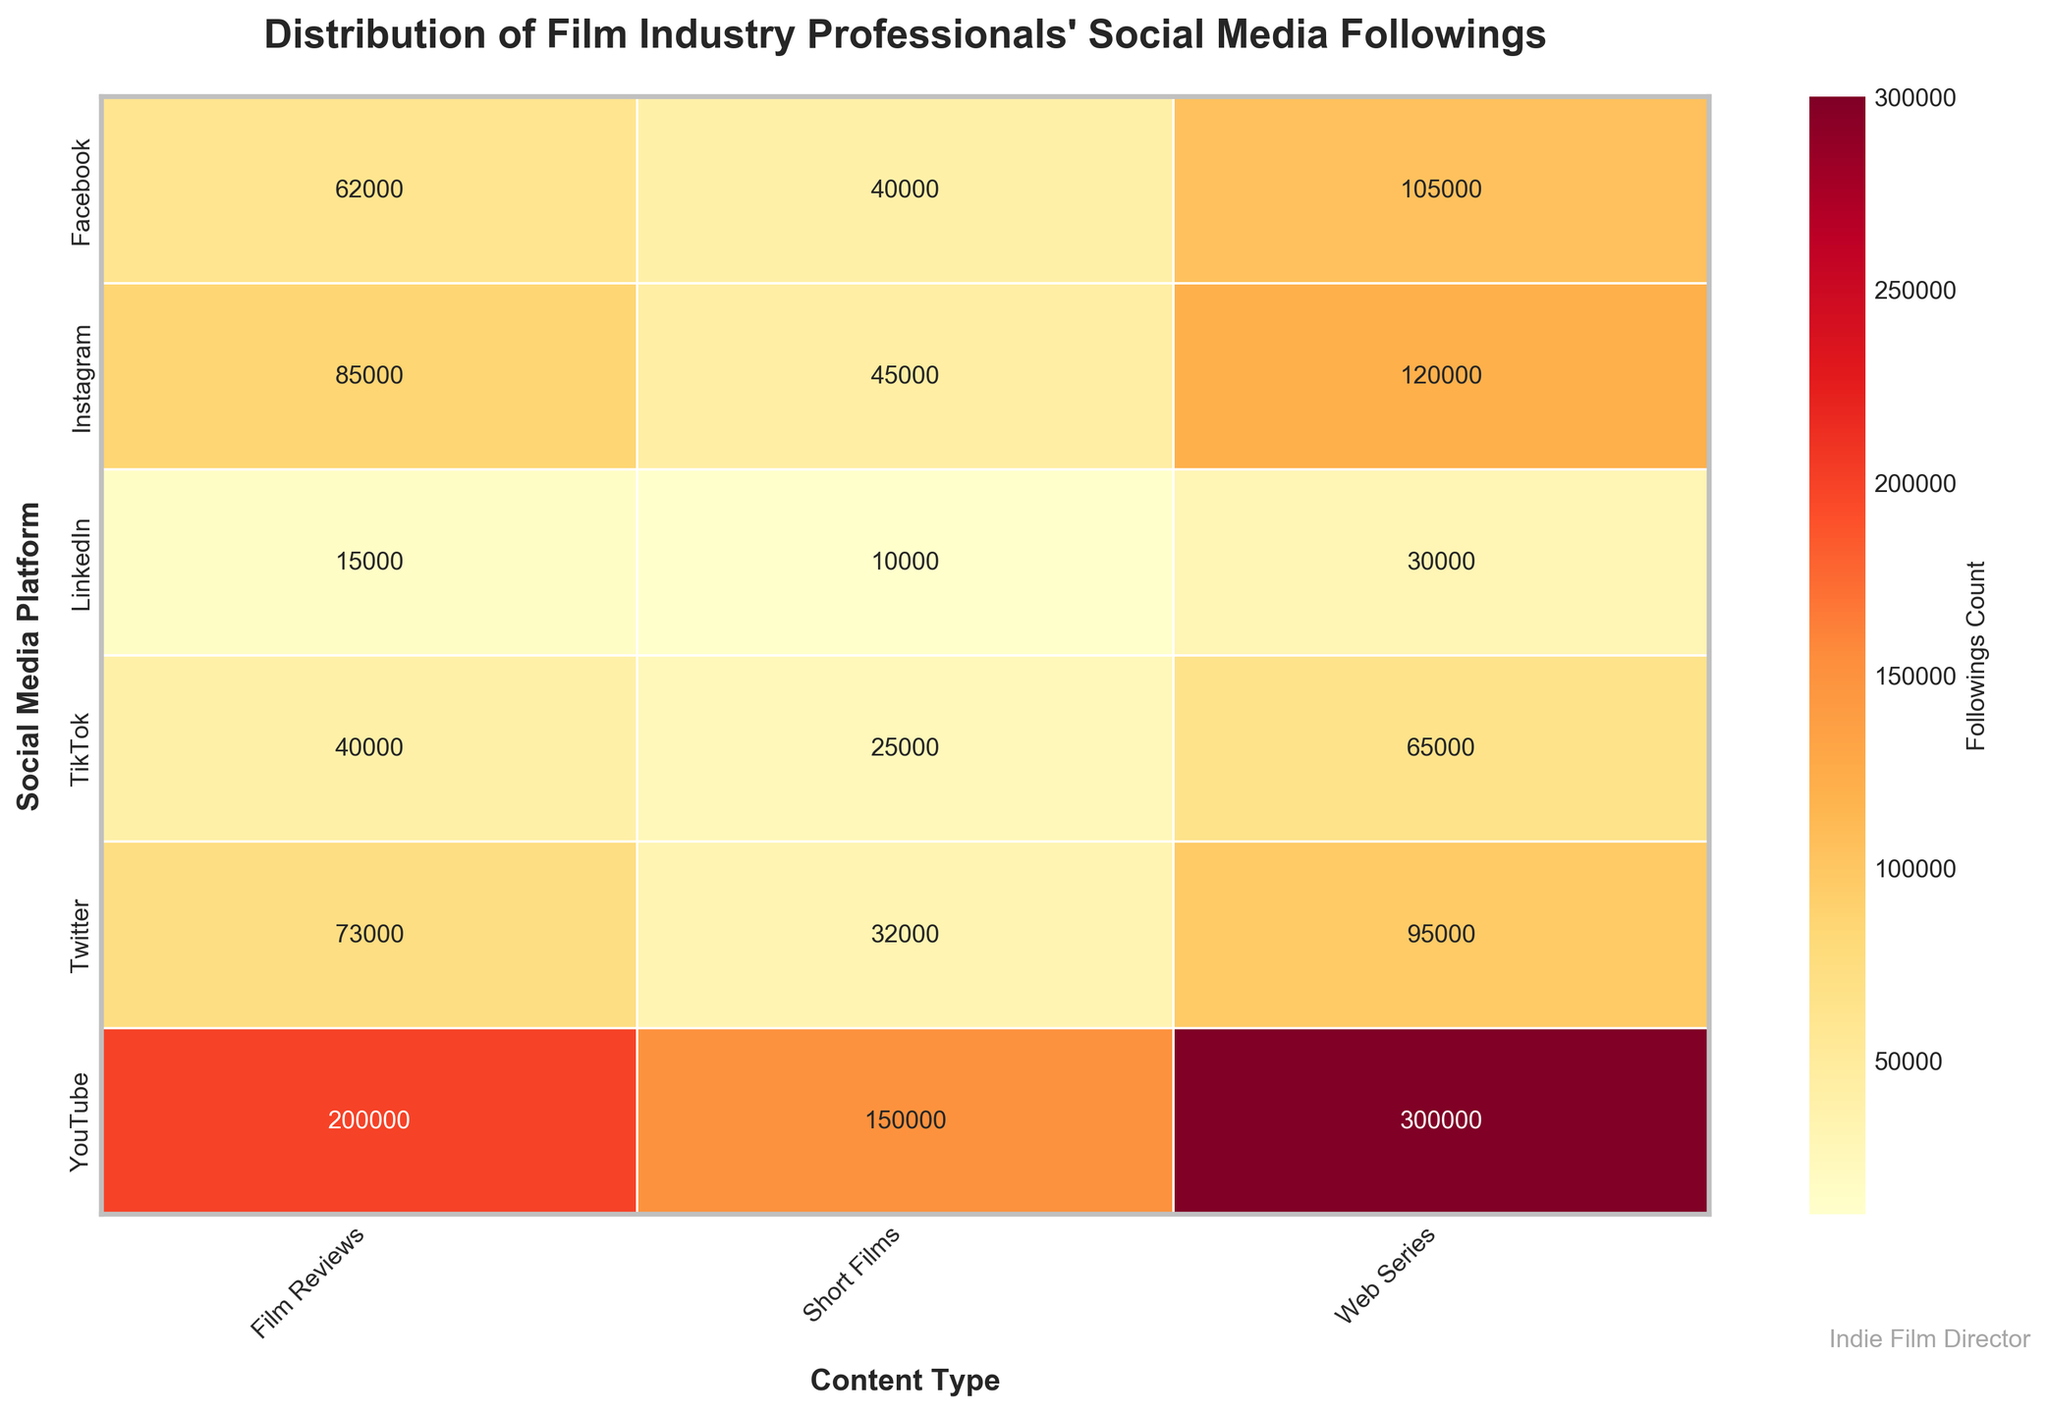What's the title of the figure? The title of the figure is written at the top, above the heatmap. It summarizes what the figure represents.
Answer: Distribution of Film Industry Professionals' Social Media Followings What does the color gradient in the heatmap represent? The color gradient represents the followings count, with lighter colors indicating lower values and darker colors indicating higher values. This can be derived from the color bar labeled "Followings Count" that accompanies the heatmap.
Answer: Followings Count Which platform and content type combination has the highest followings count? To determine this, look for the darkest cell in the heatmap, indicating the highest followings count. The combination of "YouTube" and "Web Series" shows the darkest color.
Answer: YouTube and Web Series Which social media platform has the overall lowest followings count for film reviews? Observe the heatmap cells under the "Film Reviews" column and identify the platform with the lightest color, indicating the lowest followings count. This occurs under "LinkedIn."
Answer: LinkedIn What is the combined followings count for short films on Instagram and Twitter? Locate the followings count for short films on both Instagram and Twitter in the heatmap, and then sum these values: 45000 (Instagram) + 32000 (Twitter).
Answer: 77000 How many different content types are analyzed in the heatmap? Count the number of columns representing content types in the heatmap.
Answer: 3 What is the average followings count for web series creators on TikTok and LinkedIn? Identify the followings count for web series on TikTok and LinkedIn: 65000 (TikTok) and 30000 (LinkedIn). Calculate the average: (65000 + 30000)/2.
Answer: 47500 Between Facebook and YouTube, which has more followings for film reviews? Compare the followings count for film reviews on Facebook and YouTube in the heatmap. Facebook shows 62000, whereas YouTube has 200000.
Answer: YouTube Are there any platforms where film reviews have a higher followings count than short films? Compare the cells for film reviews and short films within each platform. Check if any platform's followings count for film reviews exceeds that for short films.
Answer: Yes (Instagram, Twitter, Facebook, YouTube, TikTok, LinkedIn) Which social media platform has the most platforms where the followings count for web series exceeds 100,000? Examine each platform and count the instances where the followings count for web series is above 100,000. Find the platform with the highest count.
Answer: YouTube (300000) has more than 100,000 followings 